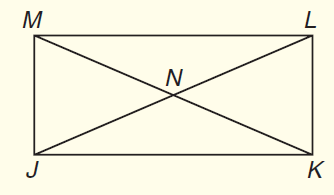Answer the mathemtical geometry problem and directly provide the correct option letter.
Question: In rectangle J K L M shown below, J L and M K are diagonals. If J L = 2 x + 5 and K M = 4 x - 11, what is x?
Choices: A: 5 B: 6 C: 8 D: 10 C 